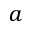<formula> <loc_0><loc_0><loc_500><loc_500>a</formula> 